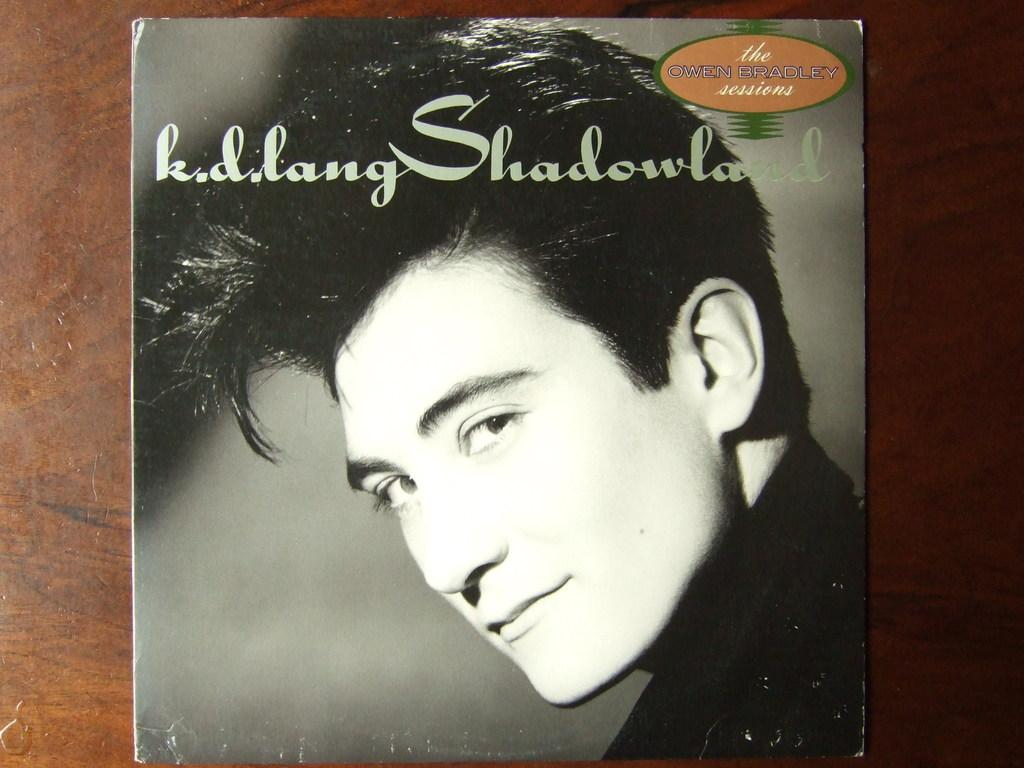What is the main subject of the image? There is a photo of a man in the image. Can you describe any text or writing in the image? Yes, there is something written on an object in the image. What color scheme is used in the image? The image is black and white in color. How many rabbits can be seen hopping in the image? There are no rabbits present in the image. What type of powder is being used by the man in the image? There is no powder or any indication of its use in the image. 